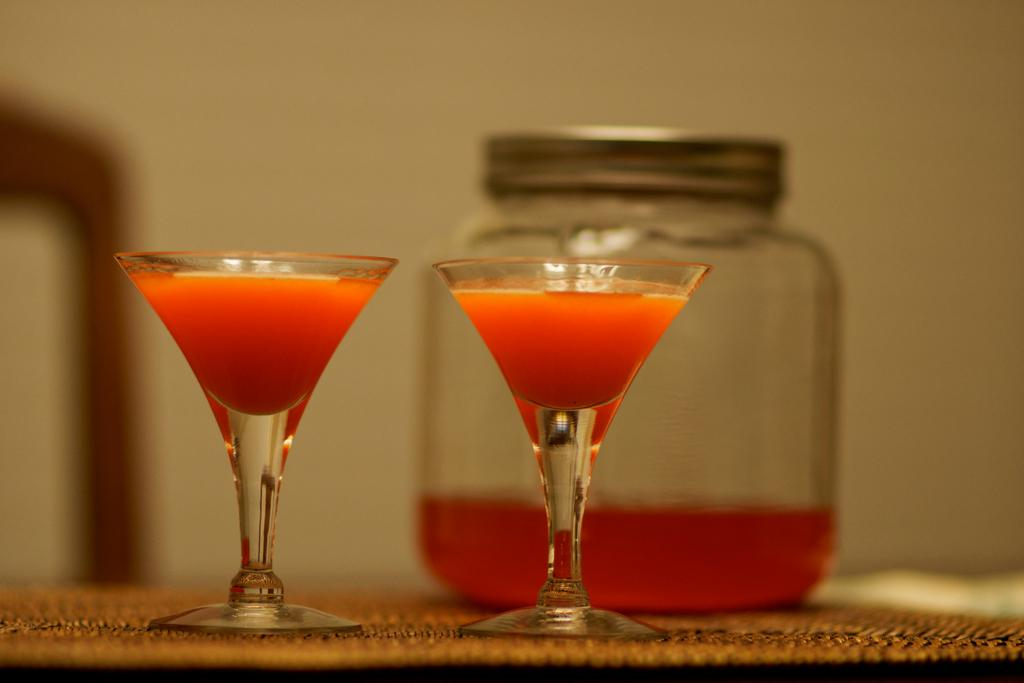What can be seen in the glasses in the image? There are two glasses filled with a drink in the image. What can be seen in the background of the image? There are trees visible in the background of the image. What is the jar in the image used for? The jar in the image has a closed lid, which suggests it is used for storing something. Can you see a river flowing through the image? There is no river visible in the image. How many crows are perched on the roof in the image? There is no roof or crow present in the image. 